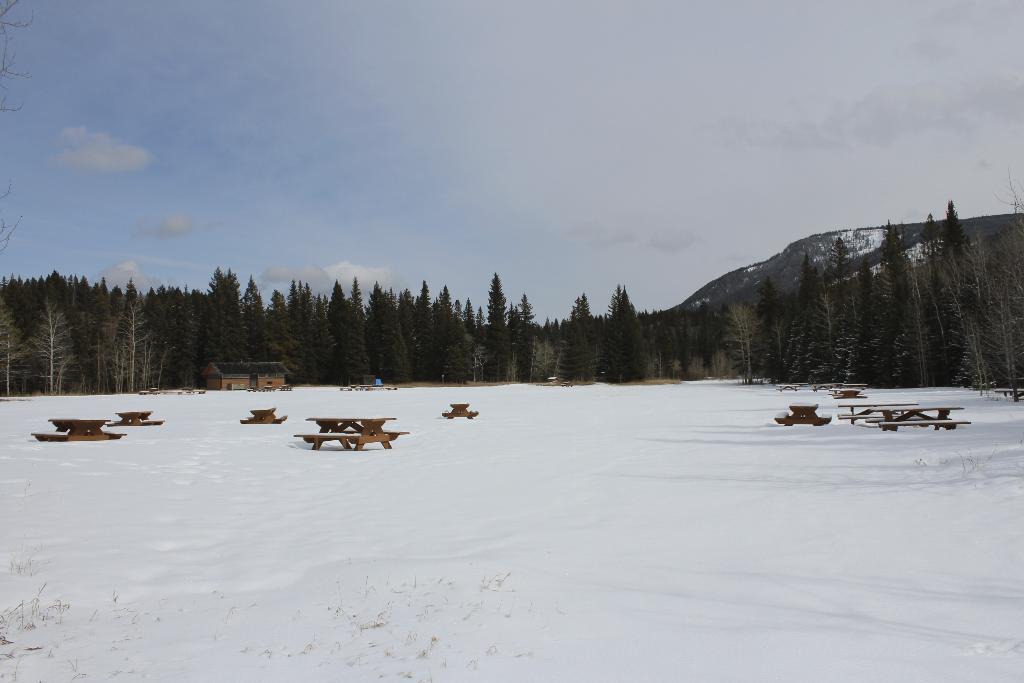In one or two sentences, can you explain what this image depicts? This image consists of benches in the middle. There are trees in the middle. There is sky at the top. There is ice in this image. 